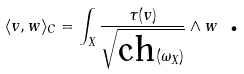<formula> <loc_0><loc_0><loc_500><loc_500>\langle v , w \rangle _ { C } = \int _ { X } \frac { \tau ( v ) } { \sqrt { \text {ch} ( \omega _ { X } ) } } \wedge w \text { . }</formula> 